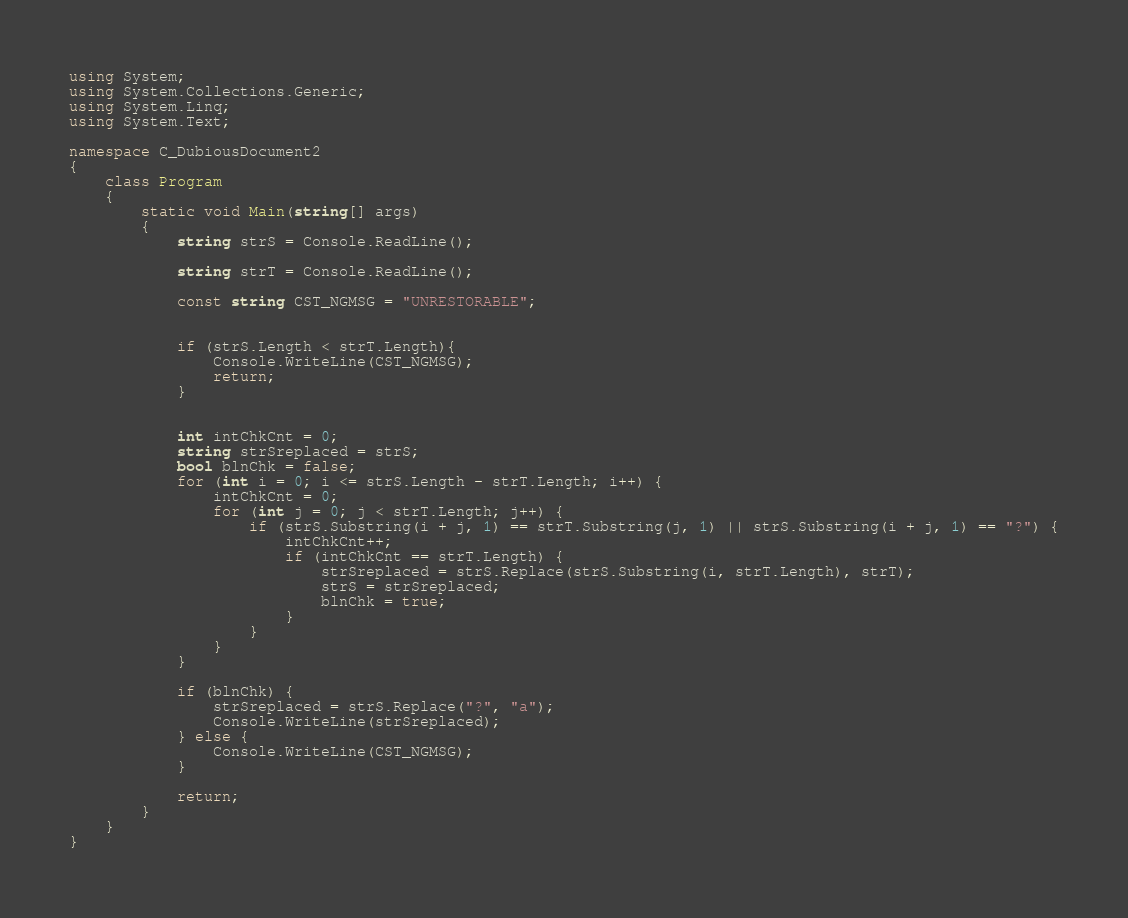Convert code to text. <code><loc_0><loc_0><loc_500><loc_500><_C#_>using System;
using System.Collections.Generic;
using System.Linq;
using System.Text;

namespace C_DubiousDocument2
{
    class Program
    {
        static void Main(string[] args)
        {
            string strS = Console.ReadLine();

            string strT = Console.ReadLine();

            const string CST_NGMSG = "UNRESTORABLE";


            if (strS.Length < strT.Length){
                Console.WriteLine(CST_NGMSG);
                return;
            }


            int intChkCnt = 0;
            string strSreplaced = strS;
            bool blnChk = false;
            for (int i = 0; i <= strS.Length - strT.Length; i++) {
                intChkCnt = 0;
                for (int j = 0; j < strT.Length; j++) {
                    if (strS.Substring(i + j, 1) == strT.Substring(j, 1) || strS.Substring(i + j, 1) == "?") {
                        intChkCnt++;
                        if (intChkCnt == strT.Length) {
                            strSreplaced = strS.Replace(strS.Substring(i, strT.Length), strT);
                            strS = strSreplaced;
                            blnChk = true;
                        }
                    }
                }
            }

            if (blnChk) {
                strSreplaced = strS.Replace("?", "a");
                Console.WriteLine(strSreplaced);
            } else { 
                Console.WriteLine(CST_NGMSG);
            }

            return;
        }
    }
}
</code> 